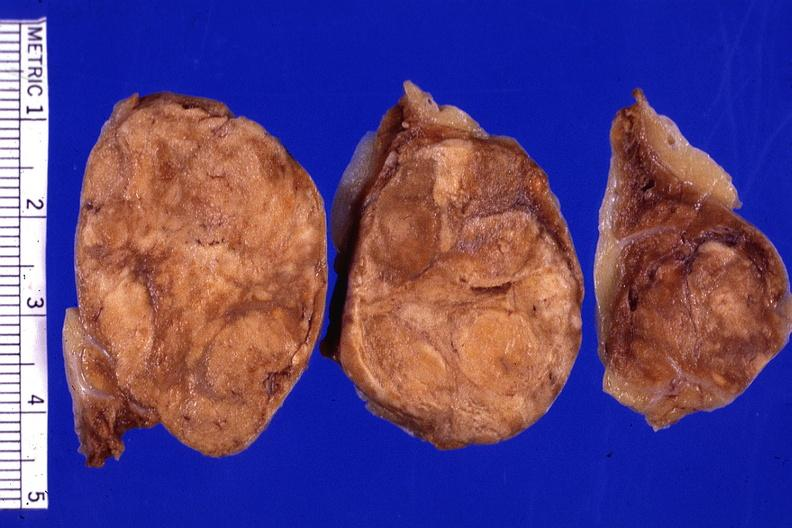how many cm does this image show cut surface lesion very good?
Answer the question using a single word or phrase. 3 